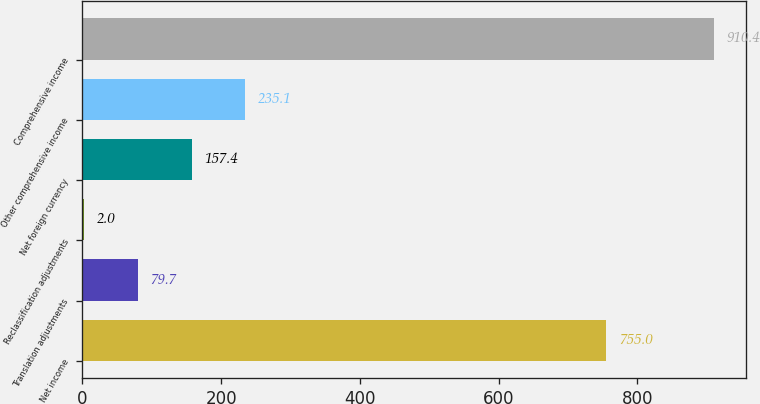Convert chart to OTSL. <chart><loc_0><loc_0><loc_500><loc_500><bar_chart><fcel>Net income<fcel>Translation adjustments<fcel>Reclassification adjustments<fcel>Net foreign currency<fcel>Other comprehensive income<fcel>Comprehensive income<nl><fcel>755<fcel>79.7<fcel>2<fcel>157.4<fcel>235.1<fcel>910.4<nl></chart> 